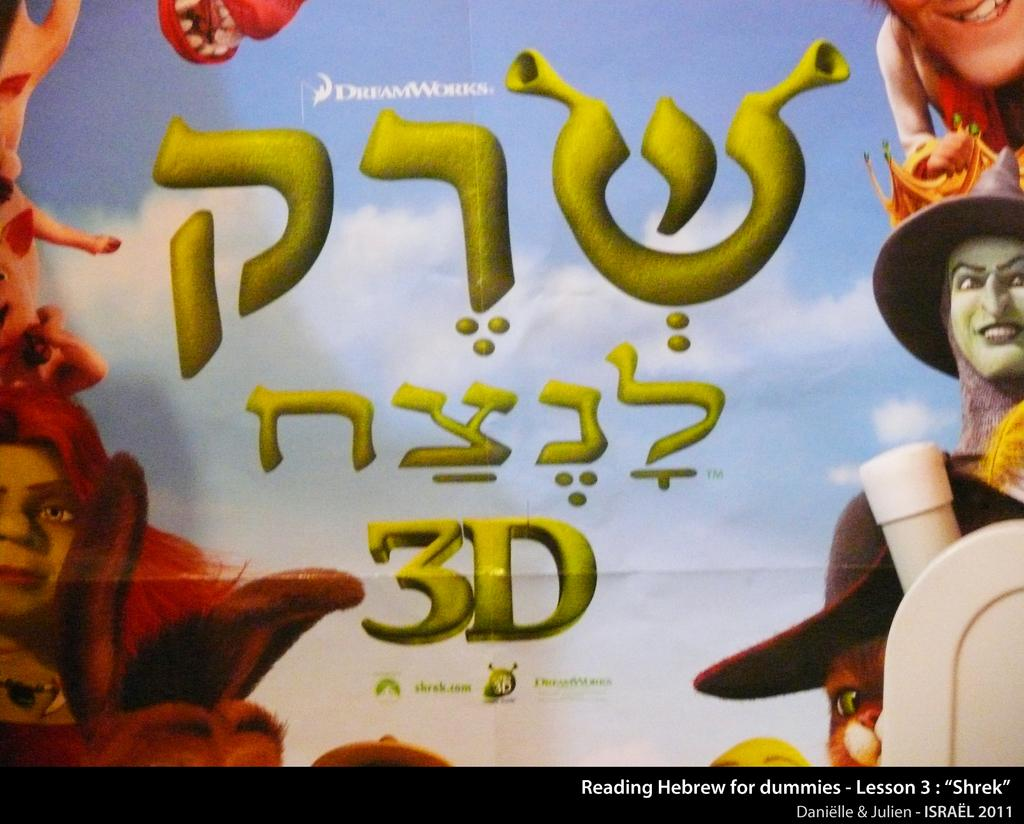What type of image is being described? The image is a poster. What is the poster promoting? The poster is for an animated movie. Is there any text on the poster? Yes, there is text written on the poster. How many clocks are featured on the poster? There are no clocks present on the poster. What type of flag is shown in the poster? There is no flag shown in the poster. 